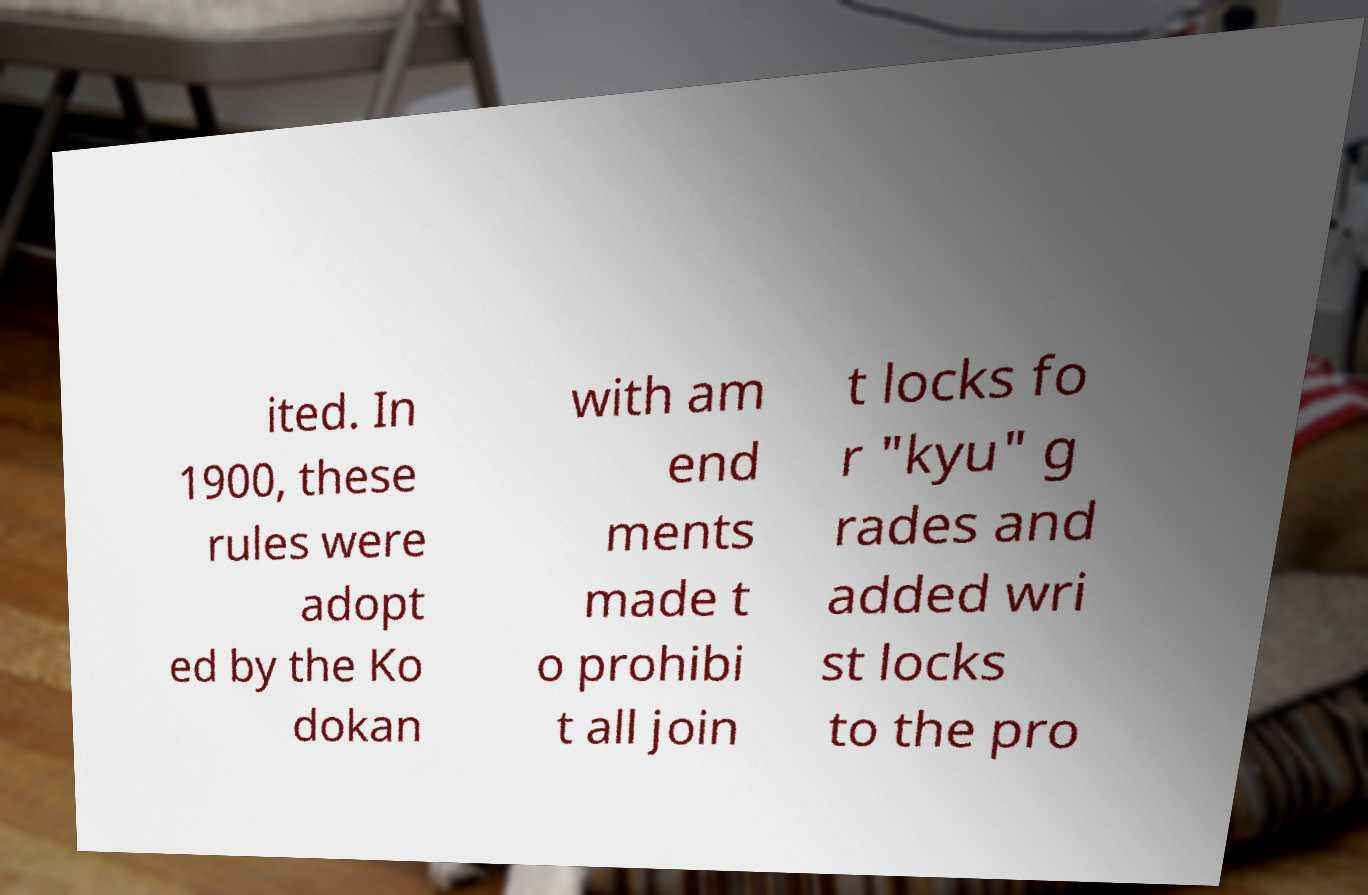Could you extract and type out the text from this image? ited. In 1900, these rules were adopt ed by the Ko dokan with am end ments made t o prohibi t all join t locks fo r "kyu" g rades and added wri st locks to the pro 